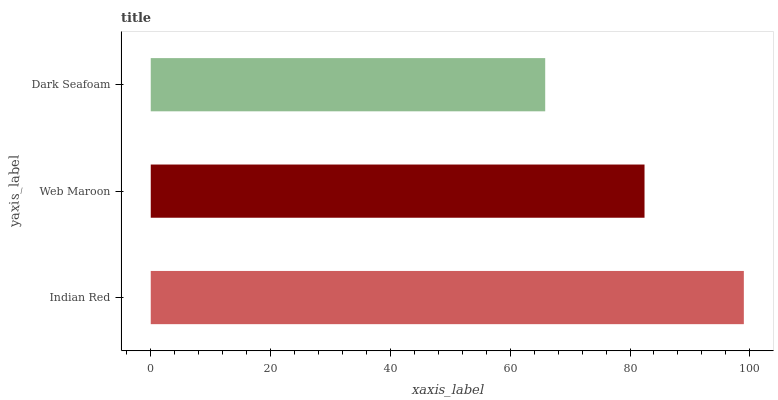Is Dark Seafoam the minimum?
Answer yes or no. Yes. Is Indian Red the maximum?
Answer yes or no. Yes. Is Web Maroon the minimum?
Answer yes or no. No. Is Web Maroon the maximum?
Answer yes or no. No. Is Indian Red greater than Web Maroon?
Answer yes or no. Yes. Is Web Maroon less than Indian Red?
Answer yes or no. Yes. Is Web Maroon greater than Indian Red?
Answer yes or no. No. Is Indian Red less than Web Maroon?
Answer yes or no. No. Is Web Maroon the high median?
Answer yes or no. Yes. Is Web Maroon the low median?
Answer yes or no. Yes. Is Dark Seafoam the high median?
Answer yes or no. No. Is Dark Seafoam the low median?
Answer yes or no. No. 